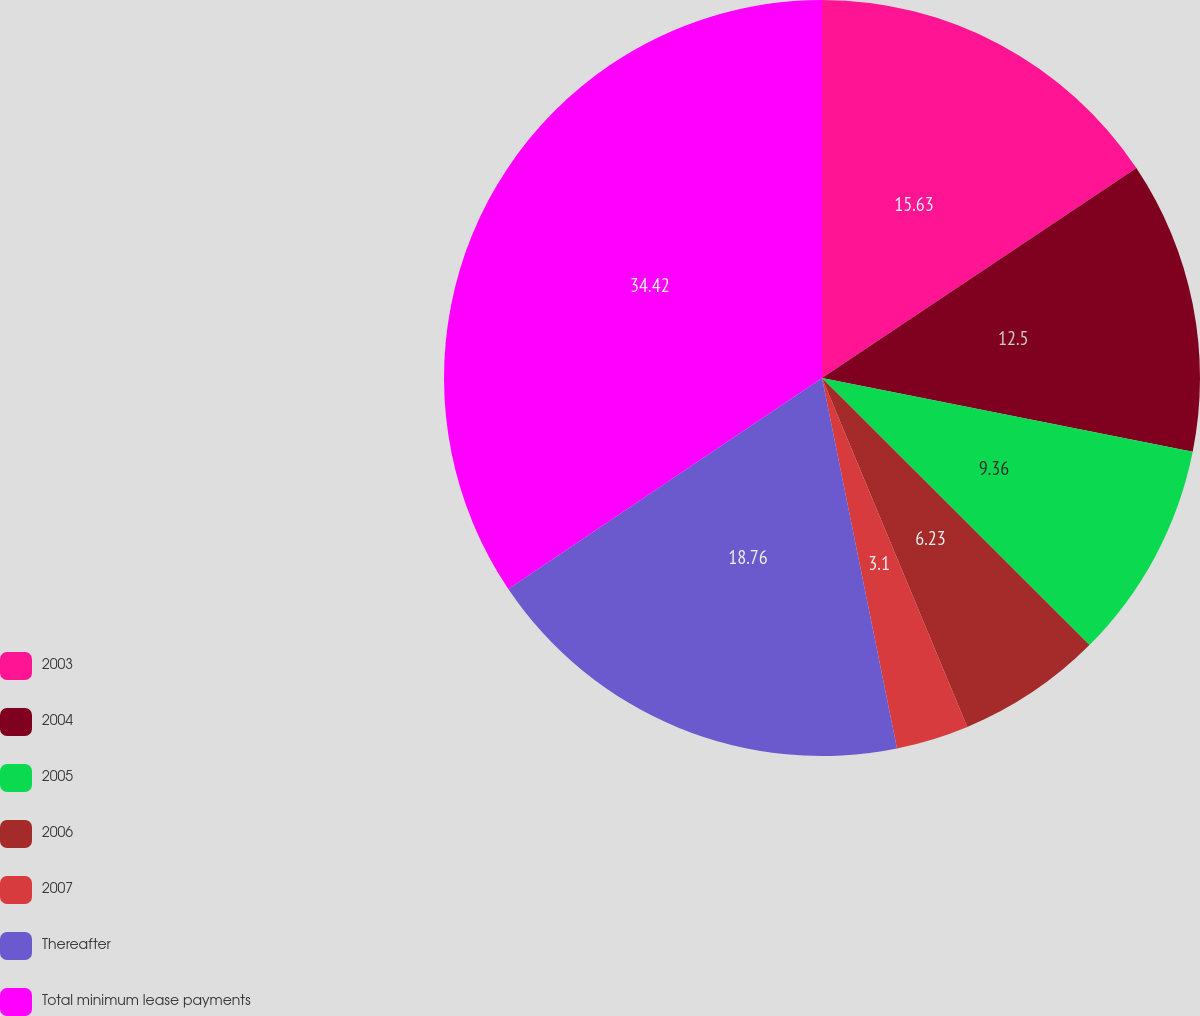<chart> <loc_0><loc_0><loc_500><loc_500><pie_chart><fcel>2003<fcel>2004<fcel>2005<fcel>2006<fcel>2007<fcel>Thereafter<fcel>Total minimum lease payments<nl><fcel>15.63%<fcel>12.5%<fcel>9.36%<fcel>6.23%<fcel>3.1%<fcel>18.76%<fcel>34.42%<nl></chart> 